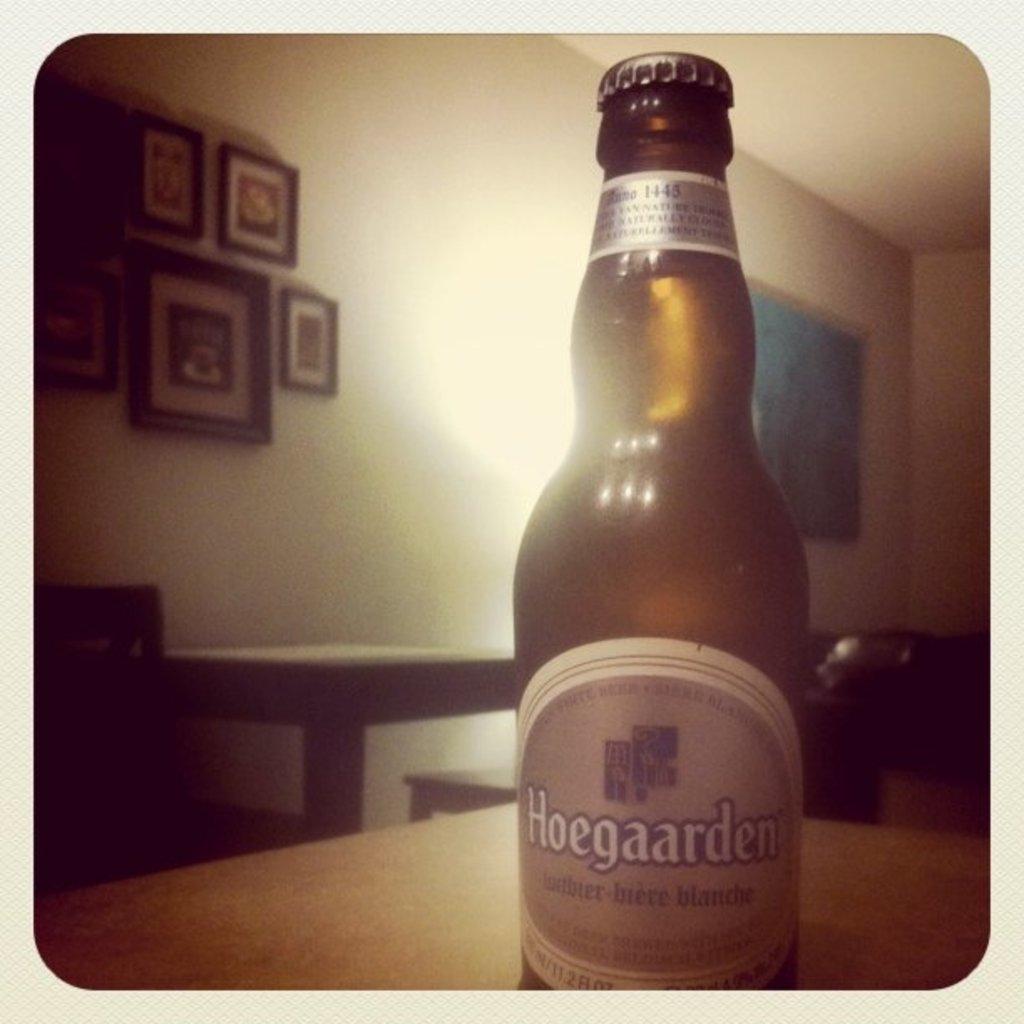What brand of beer is this?
Offer a terse response. Hoegaarden. 